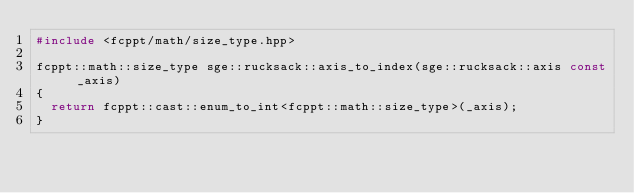Convert code to text. <code><loc_0><loc_0><loc_500><loc_500><_C++_>#include <fcppt/math/size_type.hpp>

fcppt::math::size_type sge::rucksack::axis_to_index(sge::rucksack::axis const _axis)
{
  return fcppt::cast::enum_to_int<fcppt::math::size_type>(_axis);
}
</code> 